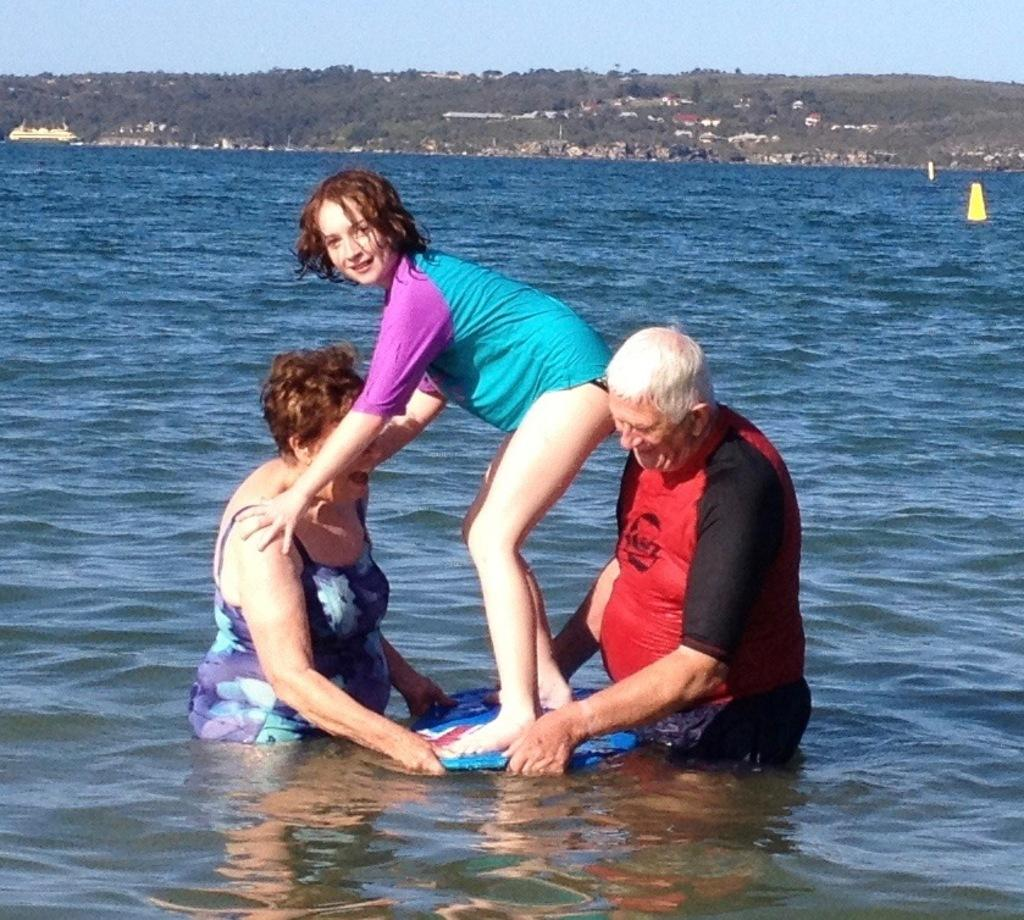How many people are in the image? There are three persons in the image. What is visible in the image besides the people? There is water visible in the image. What can be seen in the background of the image? There are trees and the sky visible in the background of the image. What type of silver material can be seen in the image? There is no silver material present in the image. Can you tell me where the nest is located in the image? There is no nest present in the image. 